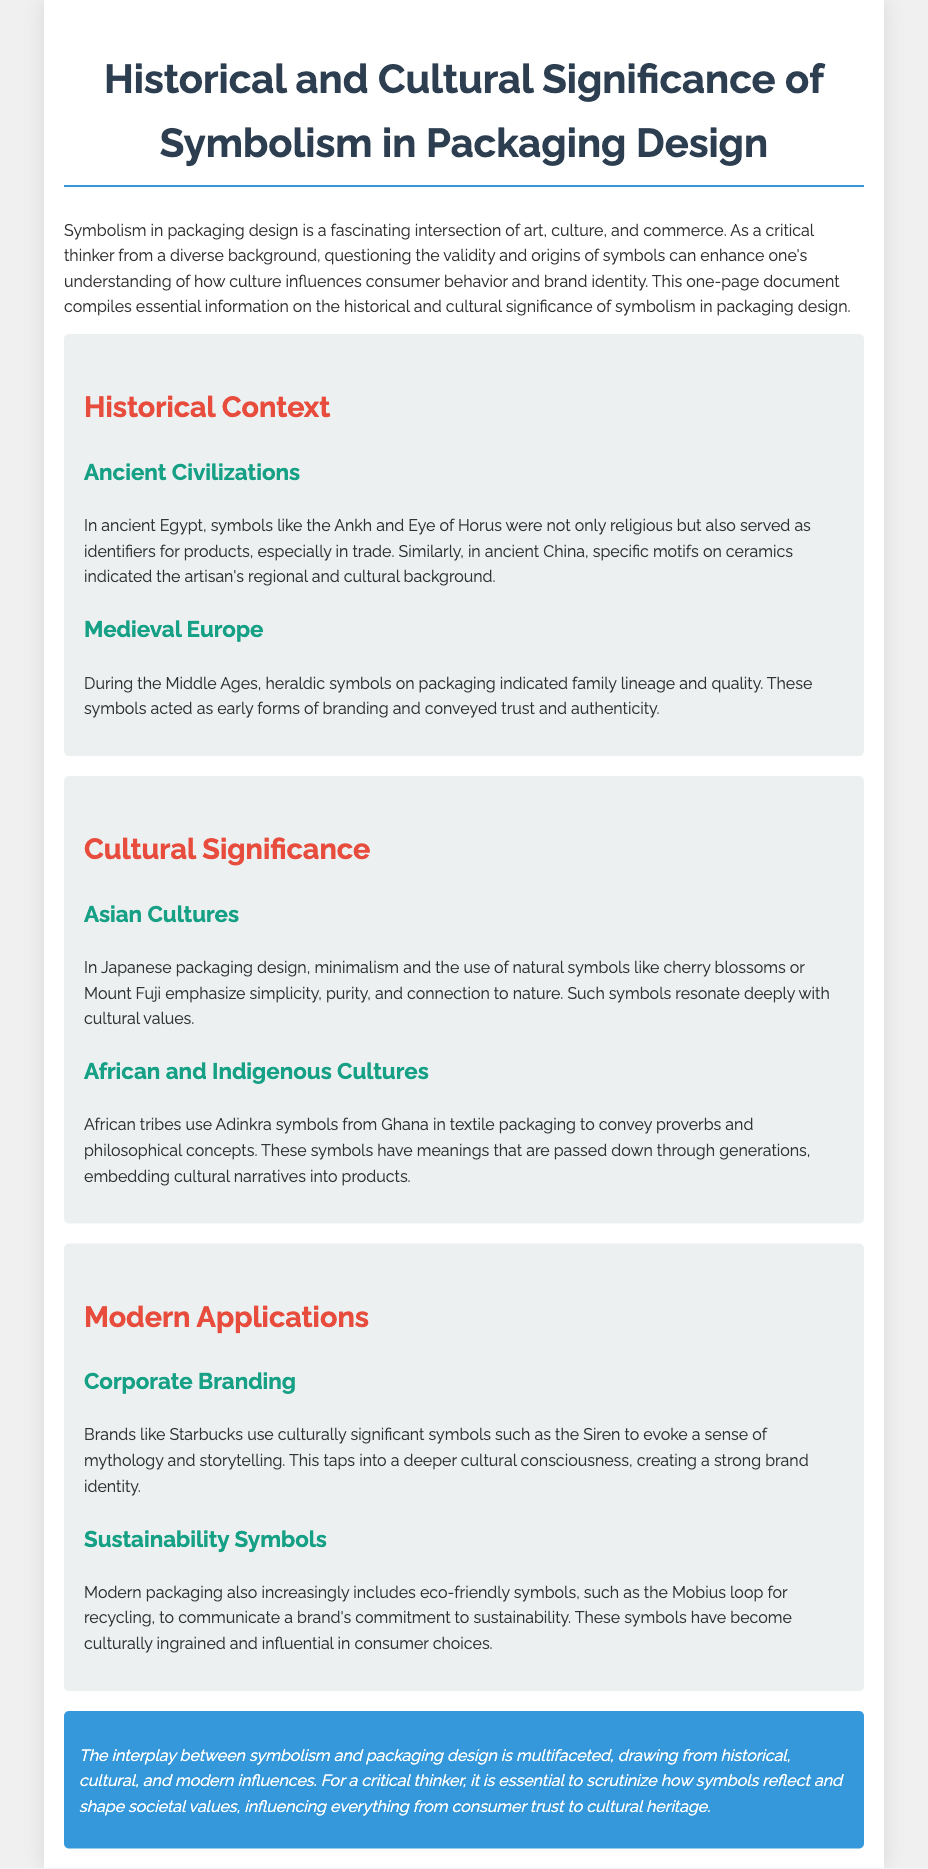what ancient symbol is mentioned as an identifier for products in Egypt? The document states that the Ankh and Eye of Horus were identifiers for products in ancient Egypt.
Answer: Ankh and Eye of Horus which cultural value does Japanese packaging design emphasize? According to the document, Japanese packaging design emphasizes simplicity, purity, and connection to nature.
Answer: Simplicity, purity, and connection to nature what was the role of heraldic symbols in medieval Europe? The document explains that heraldic symbols indicated family lineage and quality, acting as early forms of branding.
Answer: Indicated family lineage and quality what do Adinkra symbols in African cultures convey? The document mentions that Adinkra symbols convey proverbs and philosophical concepts in African cultures.
Answer: Proverbs and philosophical concepts which company uses the Siren as a culturally significant symbol? The document specifies that Starbucks uses the Siren as a culturally significant symbol.
Answer: Starbucks how do sustainability symbols influence consumer choices? The document states that eco-friendly symbols communicate a brand's commitment to sustainability, becoming culturally ingrained and influential.
Answer: Culturally ingrained and influential what is the main theme explored in this document? The document discusses the interplay between symbolism and packaging design, drawing from various influences.
Answer: Interplay between symbolism and packaging design 